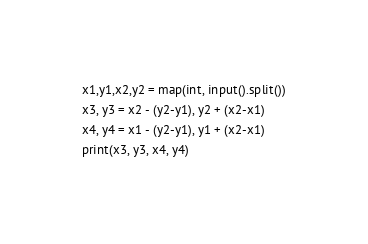Convert code to text. <code><loc_0><loc_0><loc_500><loc_500><_Python_>x1,y1,x2,y2 = map(int, input().split())
x3, y3 = x2 - (y2-y1), y2 + (x2-x1)
x4, y4 = x1 - (y2-y1), y1 + (x2-x1)
print(x3, y3, x4, y4)</code> 